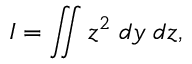<formula> <loc_0><loc_0><loc_500><loc_500>I = \iint z ^ { 2 } \, d y \, d z ,</formula> 